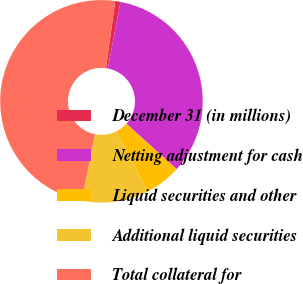Convert chart. <chart><loc_0><loc_0><loc_500><loc_500><pie_chart><fcel>December 31 (in millions)<fcel>Netting adjustment for cash<fcel>Liquid securities and other<fcel>Additional liquid securities<fcel>Total collateral for<nl><fcel>0.86%<fcel>33.65%<fcel>5.81%<fcel>10.63%<fcel>49.06%<nl></chart> 